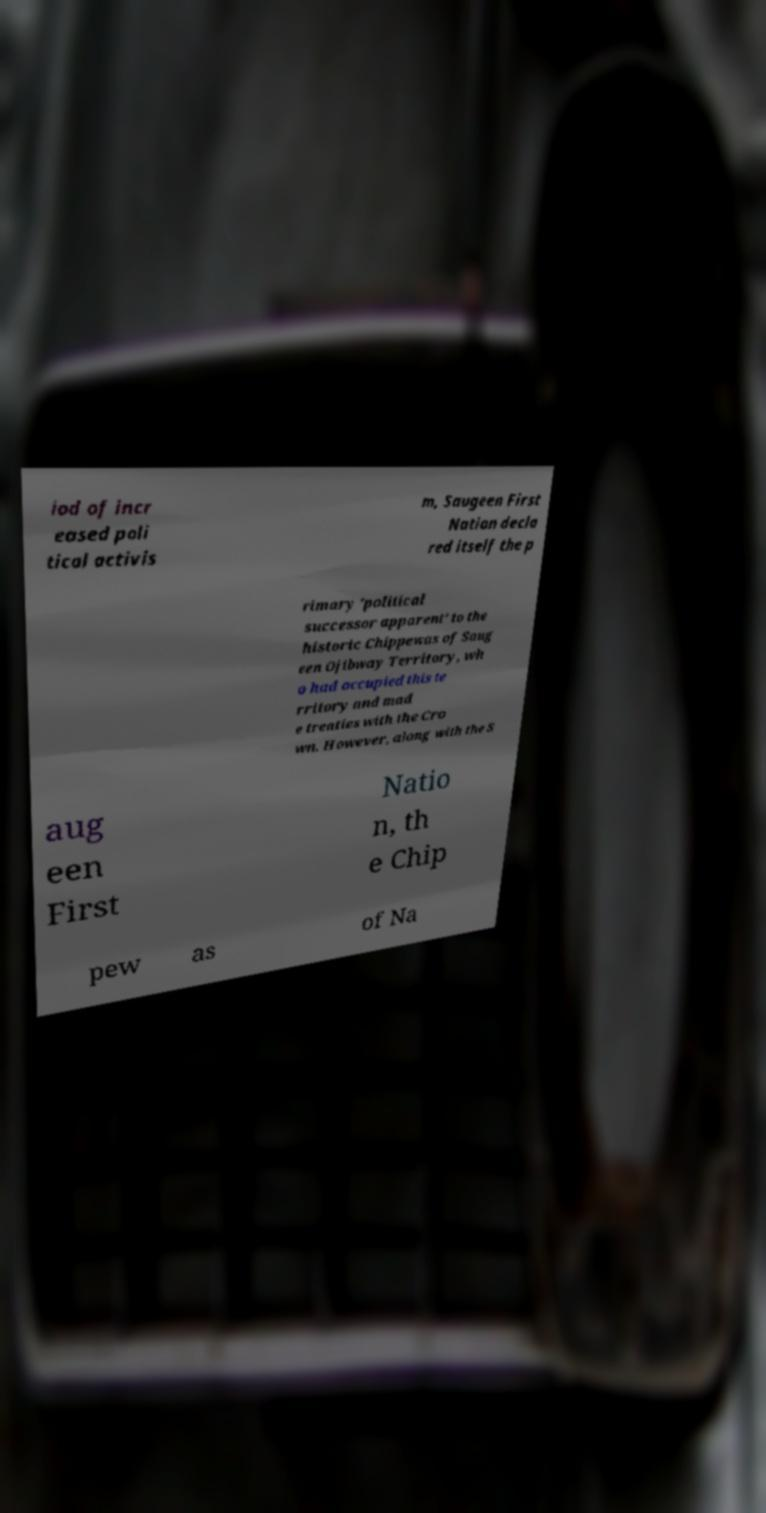Can you accurately transcribe the text from the provided image for me? iod of incr eased poli tical activis m, Saugeen First Nation decla red itself the p rimary 'political successor apparent' to the historic Chippewas of Saug een Ojibway Territory, wh o had occupied this te rritory and mad e treaties with the Cro wn. However, along with the S aug een First Natio n, th e Chip pew as of Na 